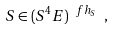Convert formula to latex. <formula><loc_0><loc_0><loc_500><loc_500>S \in ( S ^ { 4 } E ) ^ { \ f h _ { S } } \ ,</formula> 